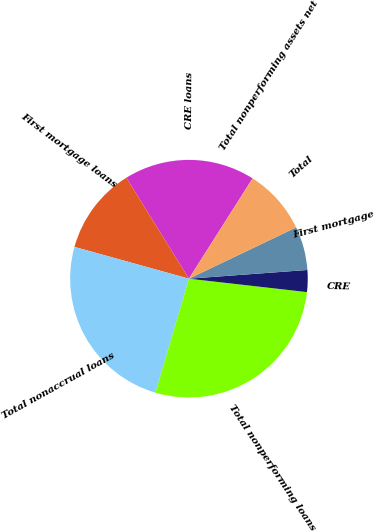<chart> <loc_0><loc_0><loc_500><loc_500><pie_chart><fcel>CRE loans<fcel>First mortgage loans<fcel>Total nonaccrual loans<fcel>Total nonperforming loans<fcel>CRE<fcel>First mortgage<fcel>Total<fcel>Total nonperforming assets net<nl><fcel>17.83%<fcel>11.86%<fcel>24.77%<fcel>27.74%<fcel>2.97%<fcel>5.93%<fcel>8.9%<fcel>0.0%<nl></chart> 